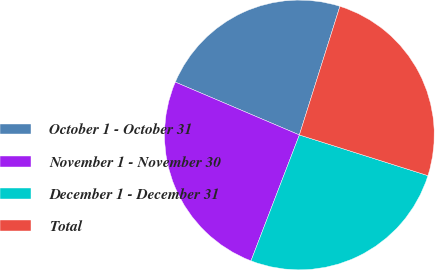<chart> <loc_0><loc_0><loc_500><loc_500><pie_chart><fcel>October 1 - October 31<fcel>November 1 - November 30<fcel>December 1 - December 31<fcel>Total<nl><fcel>23.45%<fcel>25.57%<fcel>25.96%<fcel>25.02%<nl></chart> 